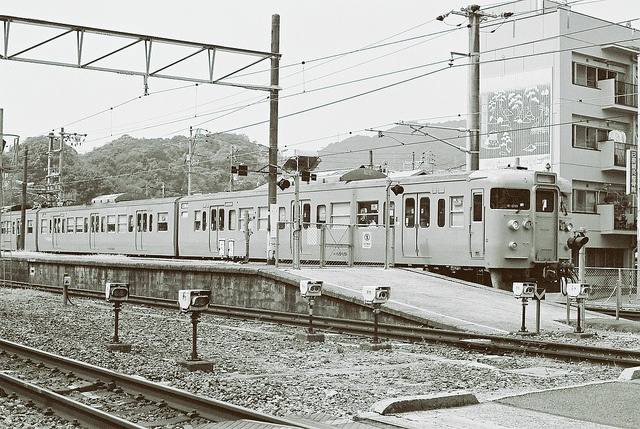Describe the objects in this image and their specific colors. I can see train in white, lightgray, darkgray, gray, and black tones, traffic light in white, gray, and black tones, traffic light in white, black, and gray tones, and traffic light in white, black, and gray tones in this image. 